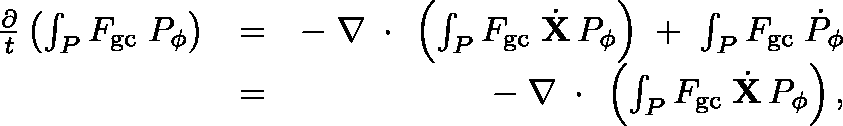<formula> <loc_0><loc_0><loc_500><loc_500>\begin{array} { r l r } { \frac { \partial } { t } \left ( \int _ { P } F _ { g c } \, P _ { \phi } \right ) } & { = } & { - \, \nabla \, \boldmath \cdot \, \left ( \int _ { P } F _ { g c } \, \dot { X } \, P _ { \phi } \right ) \, + \, \int _ { P } F _ { g c } \, \dot { P } _ { \phi } } \\ & { = } & { - \, \nabla \, \boldmath \cdot \, \left ( \int _ { P } F _ { g c } \, \dot { X } \, P _ { \phi } \right ) , } \end{array}</formula> 